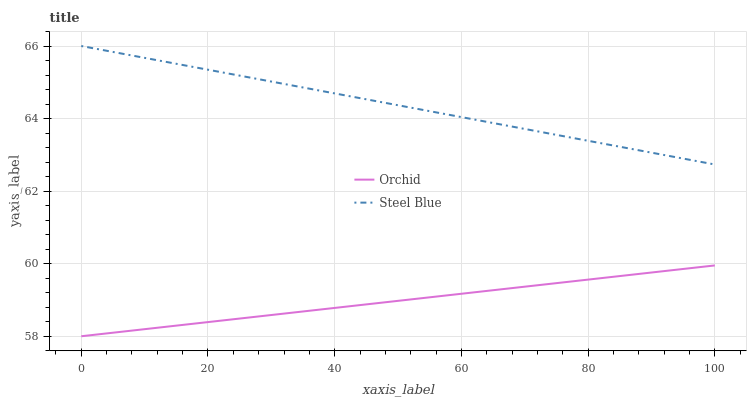Does Orchid have the minimum area under the curve?
Answer yes or no. Yes. Does Steel Blue have the maximum area under the curve?
Answer yes or no. Yes. Does Orchid have the maximum area under the curve?
Answer yes or no. No. Is Orchid the smoothest?
Answer yes or no. Yes. Is Steel Blue the roughest?
Answer yes or no. Yes. Is Orchid the roughest?
Answer yes or no. No. Does Orchid have the lowest value?
Answer yes or no. Yes. Does Steel Blue have the highest value?
Answer yes or no. Yes. Does Orchid have the highest value?
Answer yes or no. No. Is Orchid less than Steel Blue?
Answer yes or no. Yes. Is Steel Blue greater than Orchid?
Answer yes or no. Yes. Does Orchid intersect Steel Blue?
Answer yes or no. No. 